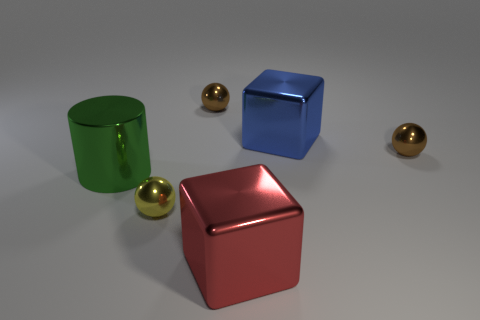What number of things are behind the cylinder?
Provide a succinct answer. 3. What is the size of the blue thing that is the same shape as the red thing?
Provide a short and direct response. Large. What size is the sphere that is in front of the blue block and left of the red thing?
Give a very brief answer. Small. Is the color of the large cylinder the same as the large shiny block behind the large green thing?
Offer a very short reply. No. What number of green things are metallic cylinders or big matte cylinders?
Your response must be concise. 1. What is the shape of the blue object?
Keep it short and to the point. Cube. How many other objects are there of the same shape as the red metallic thing?
Offer a very short reply. 1. The metal cube that is behind the big green thing is what color?
Your response must be concise. Blue. Is the yellow thing made of the same material as the big red object?
Keep it short and to the point. Yes. How many things are either spheres or small metal spheres in front of the big blue thing?
Keep it short and to the point. 3. 